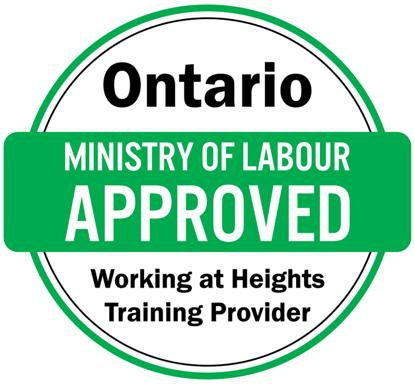What specific criteria must a 'Working at Heights Training Provider' meet to be approved by the Ontario Ministry of Labour? To be approved by the Ontario Ministry of Labour, a 'Working at Heights Training Provider' must meet criteria including comprehensive curriculum that covers all safety aspects of working at heights, such as fall prevention and emergency response plans, trained and certified instructors, and rigorous assessment methods for participants to ensure understanding and ability to apply safety measures practically. 